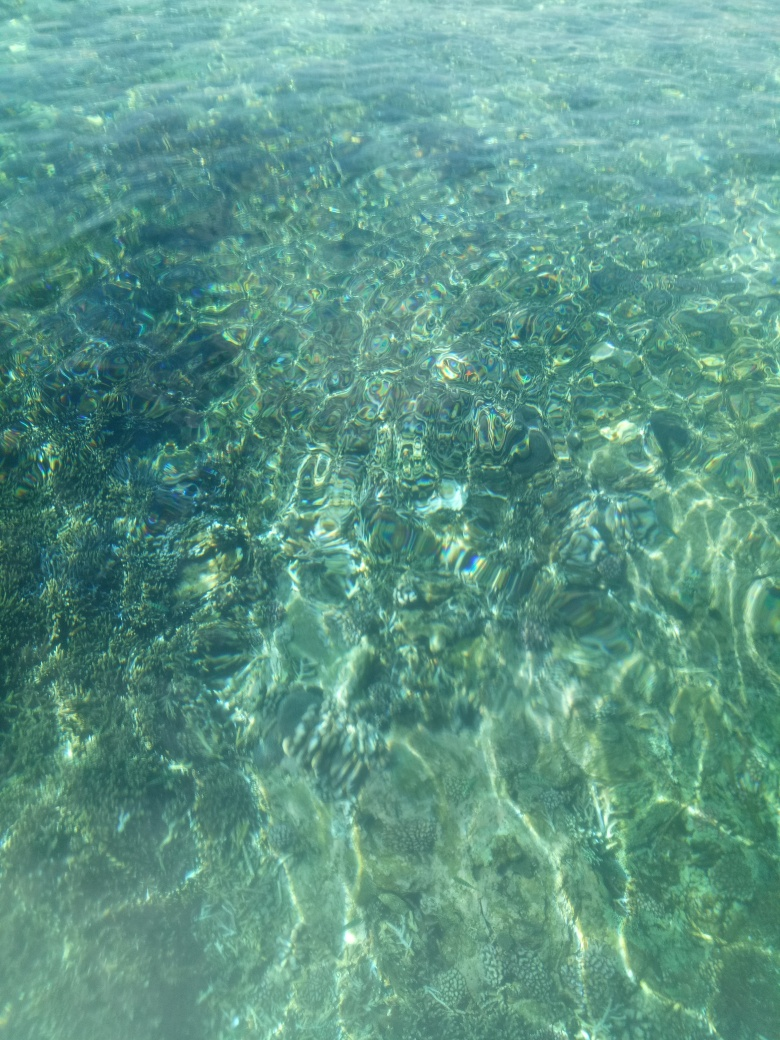Are there any indications of marine life in this photo? While the image does show a variety of textures that could be indicative of marine flora, there are no distinct shapes or movements that confirm the presence of marine animals. However, such clear waters are often rich in marine ecosystems. 